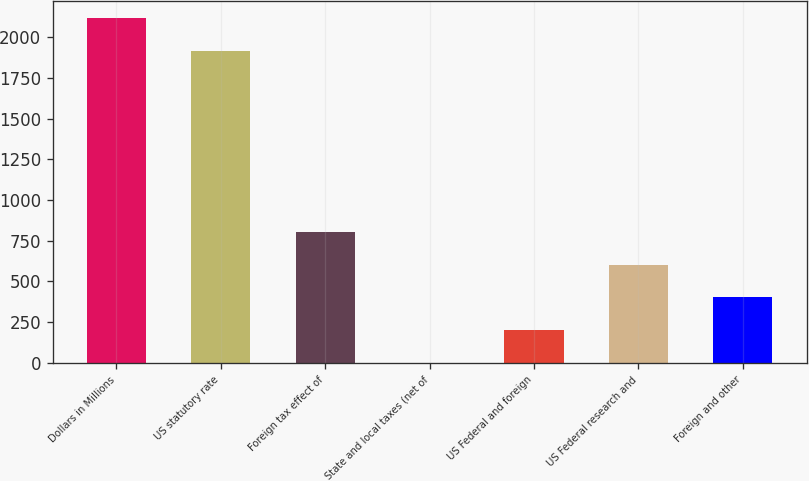Convert chart. <chart><loc_0><loc_0><loc_500><loc_500><bar_chart><fcel>Dollars in Millions<fcel>US statutory rate<fcel>Foreign tax effect of<fcel>State and local taxes (net of<fcel>US Federal and foreign<fcel>US Federal research and<fcel>Foreign and other<nl><fcel>2115.7<fcel>1915<fcel>803.8<fcel>1<fcel>201.7<fcel>603.1<fcel>402.4<nl></chart> 